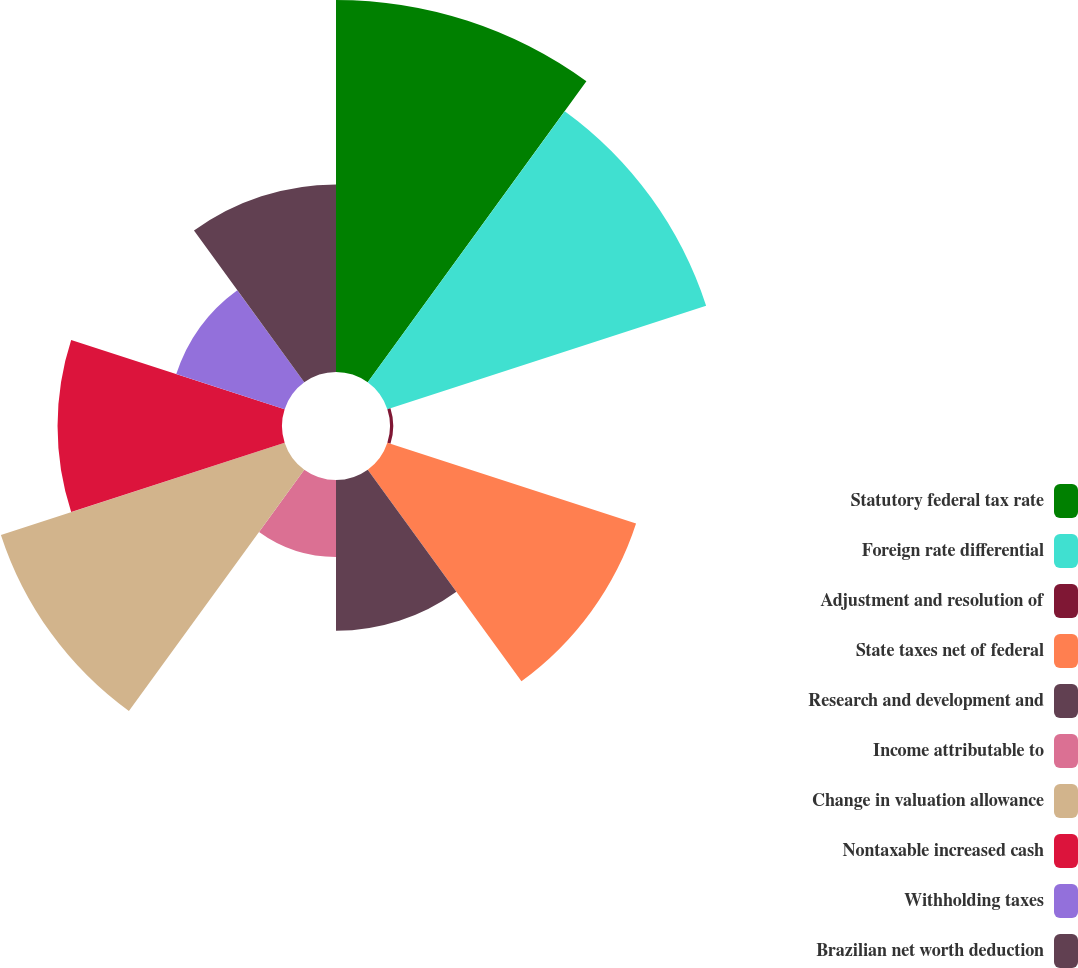Convert chart. <chart><loc_0><loc_0><loc_500><loc_500><pie_chart><fcel>Statutory federal tax rate<fcel>Foreign rate differential<fcel>Adjustment and resolution of<fcel>State taxes net of federal<fcel>Research and development and<fcel>Income attributable to<fcel>Change in valuation allowance<fcel>Nontaxable increased cash<fcel>Withholding taxes<fcel>Brazilian net worth deduction<nl><fcel>18.38%<fcel>16.56%<fcel>0.16%<fcel>12.92%<fcel>7.45%<fcel>3.8%<fcel>14.74%<fcel>11.09%<fcel>5.63%<fcel>9.27%<nl></chart> 